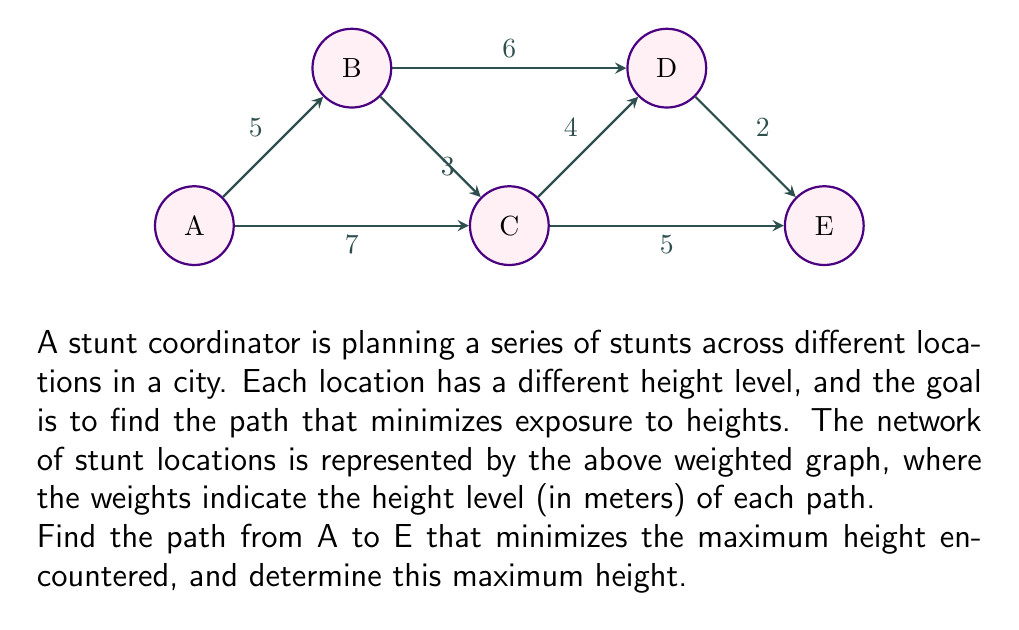What is the answer to this math problem? To solve this problem, we'll use a modified version of Dijkstra's algorithm, where instead of minimizing the sum of weights, we'll minimize the maximum weight encountered on any path.

1) Initialize distances:
   A: 0, B: ∞, C: ∞, D: ∞, E: ∞

2) Start from A:
   - Path A → B: max(0, 5) = 5
   - Path A → C: max(0, 7) = 7
   Update: A: 0, B: 5, C: 7, D: ∞, E: ∞

3) Process B:
   - Path B → C: max(5, 3) = 5
   - Path B → D: max(5, 6) = 6
   Update: A: 0, B: 5, C: 5, D: 6, E: ∞

4) Process C:
   - Path C → D: max(5, 4) = 5
   - Path C → E: max(5, 5) = 5
   Update: A: 0, B: 5, C: 5, D: 5, E: 5

5) Process D:
   - Path D → E: max(5, 2) = 5
   No change in E's value.

6) Process E:
   All nodes processed.

The shortest path that minimizes the maximum height is A → B → C → E or A → B → C → D → E, both with a maximum height of 5 meters.
Answer: The path that minimizes the maximum height is either A → B → C → E or A → B → C → D → E, with a maximum height of 5 meters. 